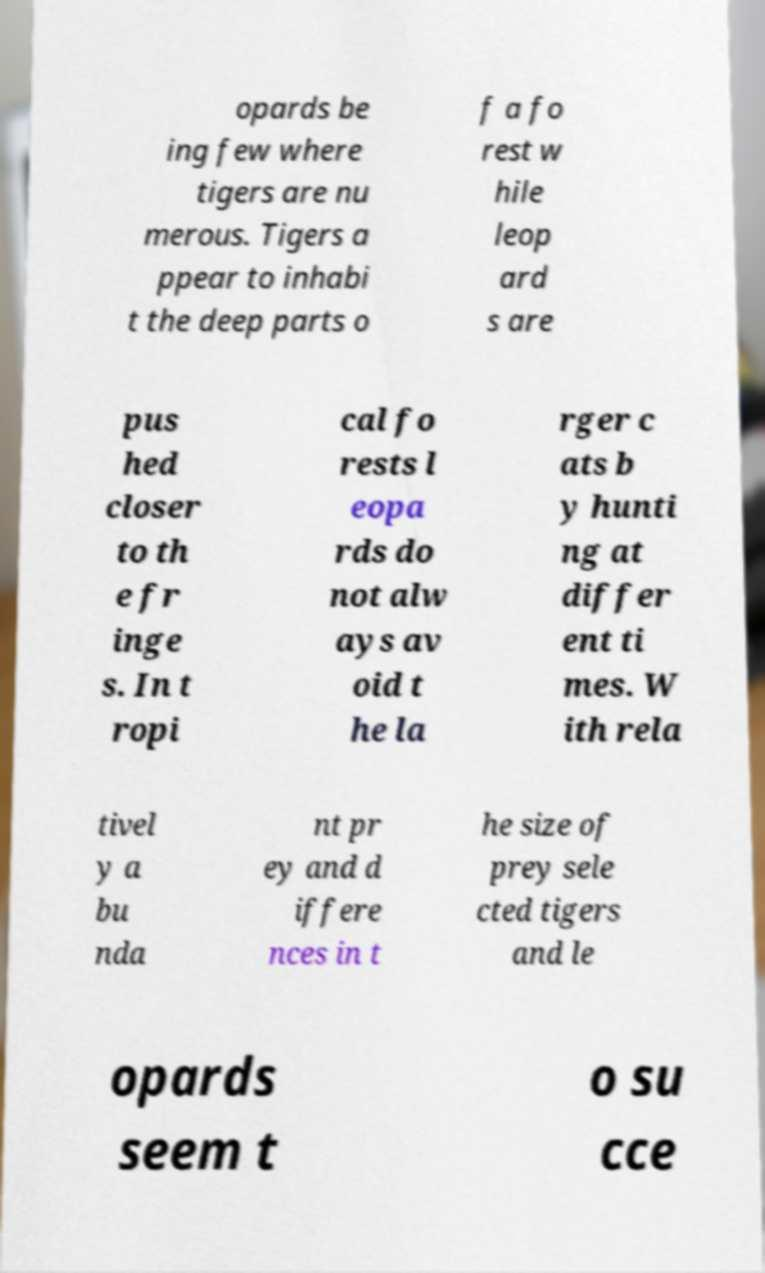There's text embedded in this image that I need extracted. Can you transcribe it verbatim? opards be ing few where tigers are nu merous. Tigers a ppear to inhabi t the deep parts o f a fo rest w hile leop ard s are pus hed closer to th e fr inge s. In t ropi cal fo rests l eopa rds do not alw ays av oid t he la rger c ats b y hunti ng at differ ent ti mes. W ith rela tivel y a bu nda nt pr ey and d iffere nces in t he size of prey sele cted tigers and le opards seem t o su cce 